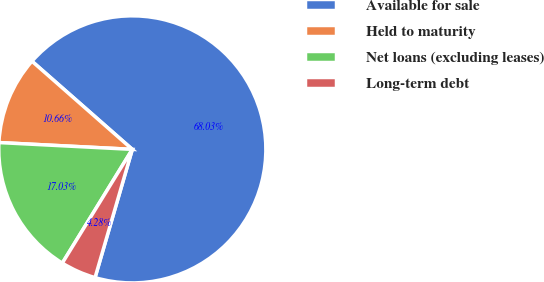<chart> <loc_0><loc_0><loc_500><loc_500><pie_chart><fcel>Available for sale<fcel>Held to maturity<fcel>Net loans (excluding leases)<fcel>Long-term debt<nl><fcel>68.03%<fcel>10.66%<fcel>17.03%<fcel>4.28%<nl></chart> 